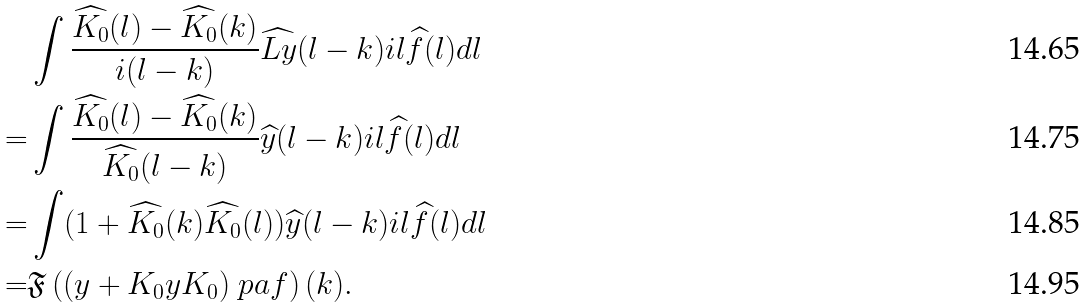Convert formula to latex. <formula><loc_0><loc_0><loc_500><loc_500>& \int \frac { \widehat { K _ { 0 } } ( l ) - \widehat { K _ { 0 } } ( k ) } { i ( l - k ) } \widehat { L y } ( l - k ) i l \widehat { f } ( l ) d l \\ = & \int \frac { \widehat { K _ { 0 } } ( l ) - \widehat { K _ { 0 } } ( k ) } { \widehat { K _ { 0 } } ( l - k ) } \widehat { y } ( l - k ) i l \widehat { f } ( l ) d l \\ = & \int ( 1 + \widehat { K _ { 0 } } ( k ) \widehat { K _ { 0 } } ( l ) ) \widehat { y } ( l - k ) i l \widehat { f } ( l ) d l \\ = & \mathfrak { F } \left ( ( y + K _ { 0 } y K _ { 0 } ) \ p a f \right ) ( k ) .</formula> 